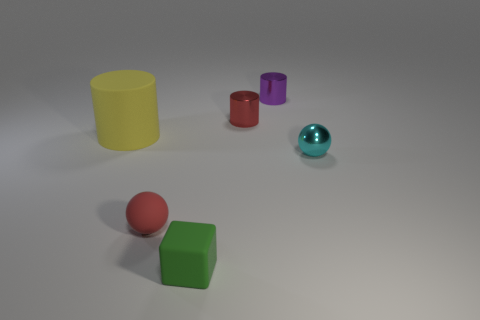Does the tiny red object on the right side of the green block have the same material as the small cube to the left of the purple cylinder?
Give a very brief answer. No. How many other objects are the same material as the purple cylinder?
Keep it short and to the point. 2. How many shiny things are cyan balls or small red objects?
Ensure brevity in your answer.  2. Is the number of cylinders less than the number of tiny green objects?
Keep it short and to the point. No. There is a matte cube; is it the same size as the yellow matte object that is left of the cyan shiny object?
Your response must be concise. No. Are there any other things that are the same shape as the small green thing?
Your answer should be very brief. No. The green matte cube has what size?
Your response must be concise. Small. Are there fewer tiny red objects that are in front of the small cyan metallic thing than big brown matte cylinders?
Offer a very short reply. No. Do the matte cube and the cyan metallic sphere have the same size?
Offer a terse response. Yes. Is there anything else that has the same size as the yellow thing?
Your answer should be very brief. No. 